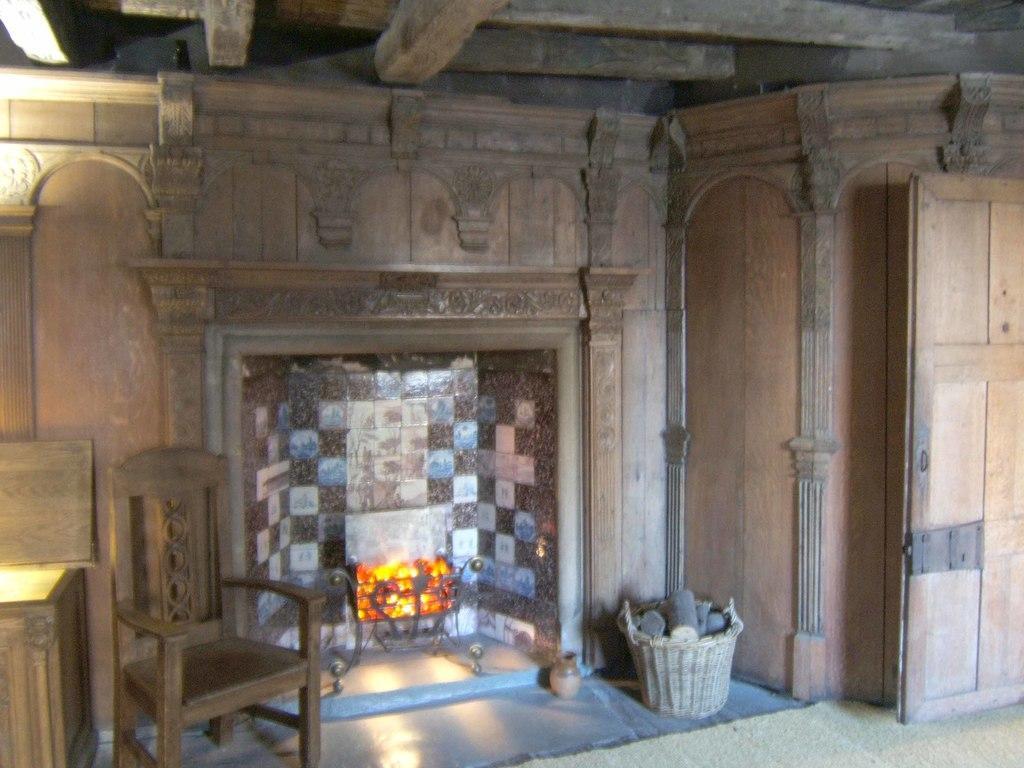Can you describe this image briefly? In the center of the image we can see a fireplace. On the left there is a table and a chair. On the right we can see a basket and a door. 